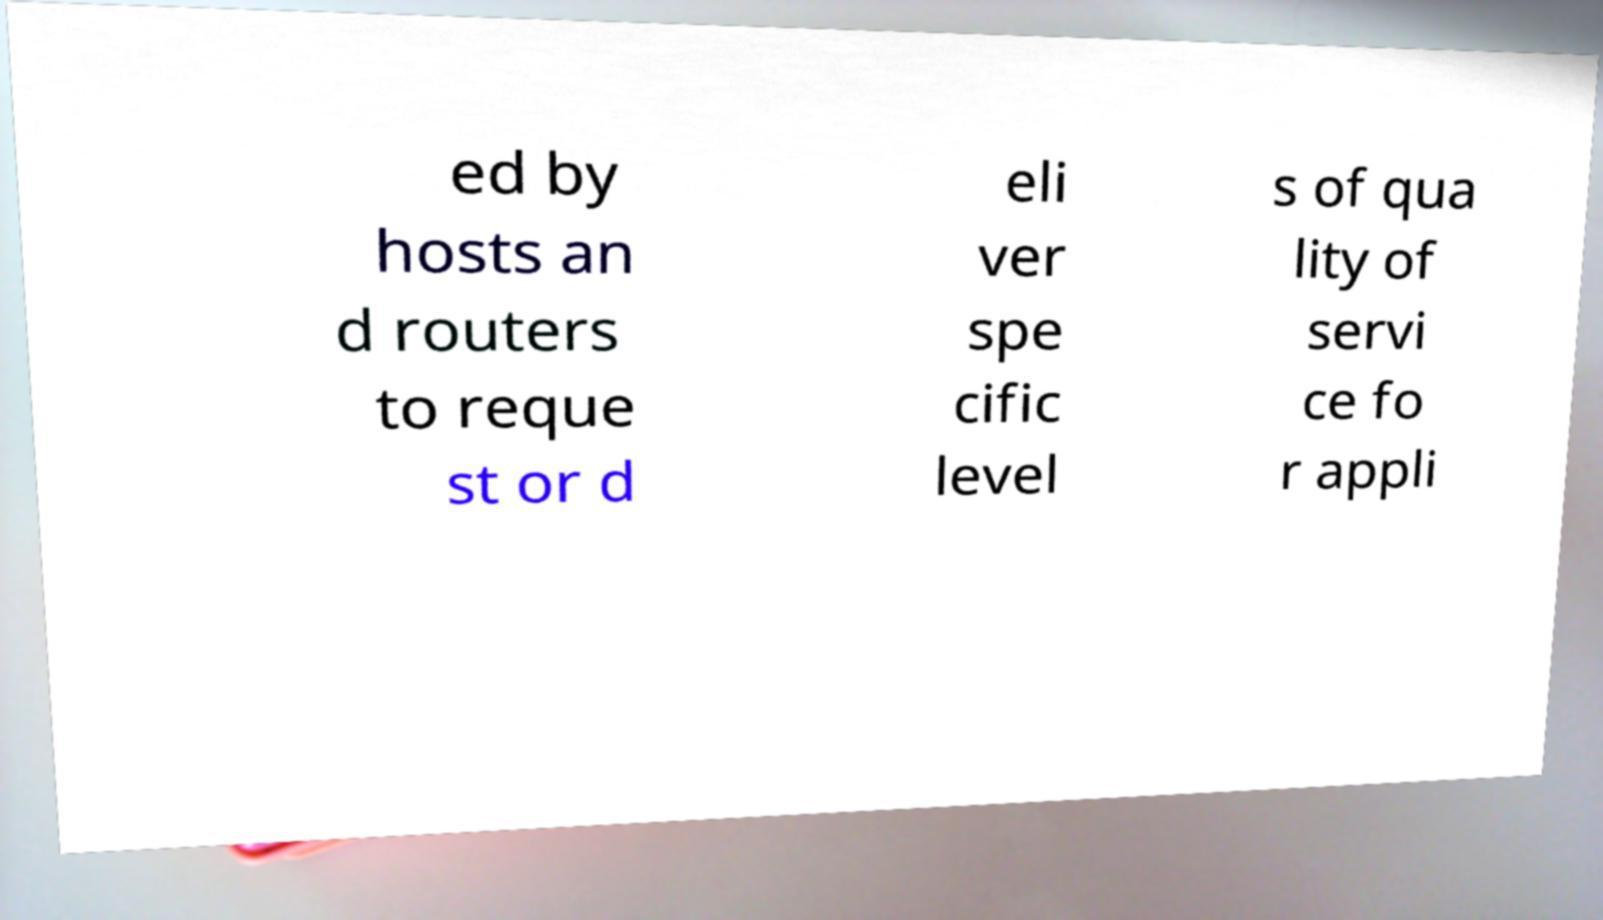For documentation purposes, I need the text within this image transcribed. Could you provide that? ed by hosts an d routers to reque st or d eli ver spe cific level s of qua lity of servi ce fo r appli 